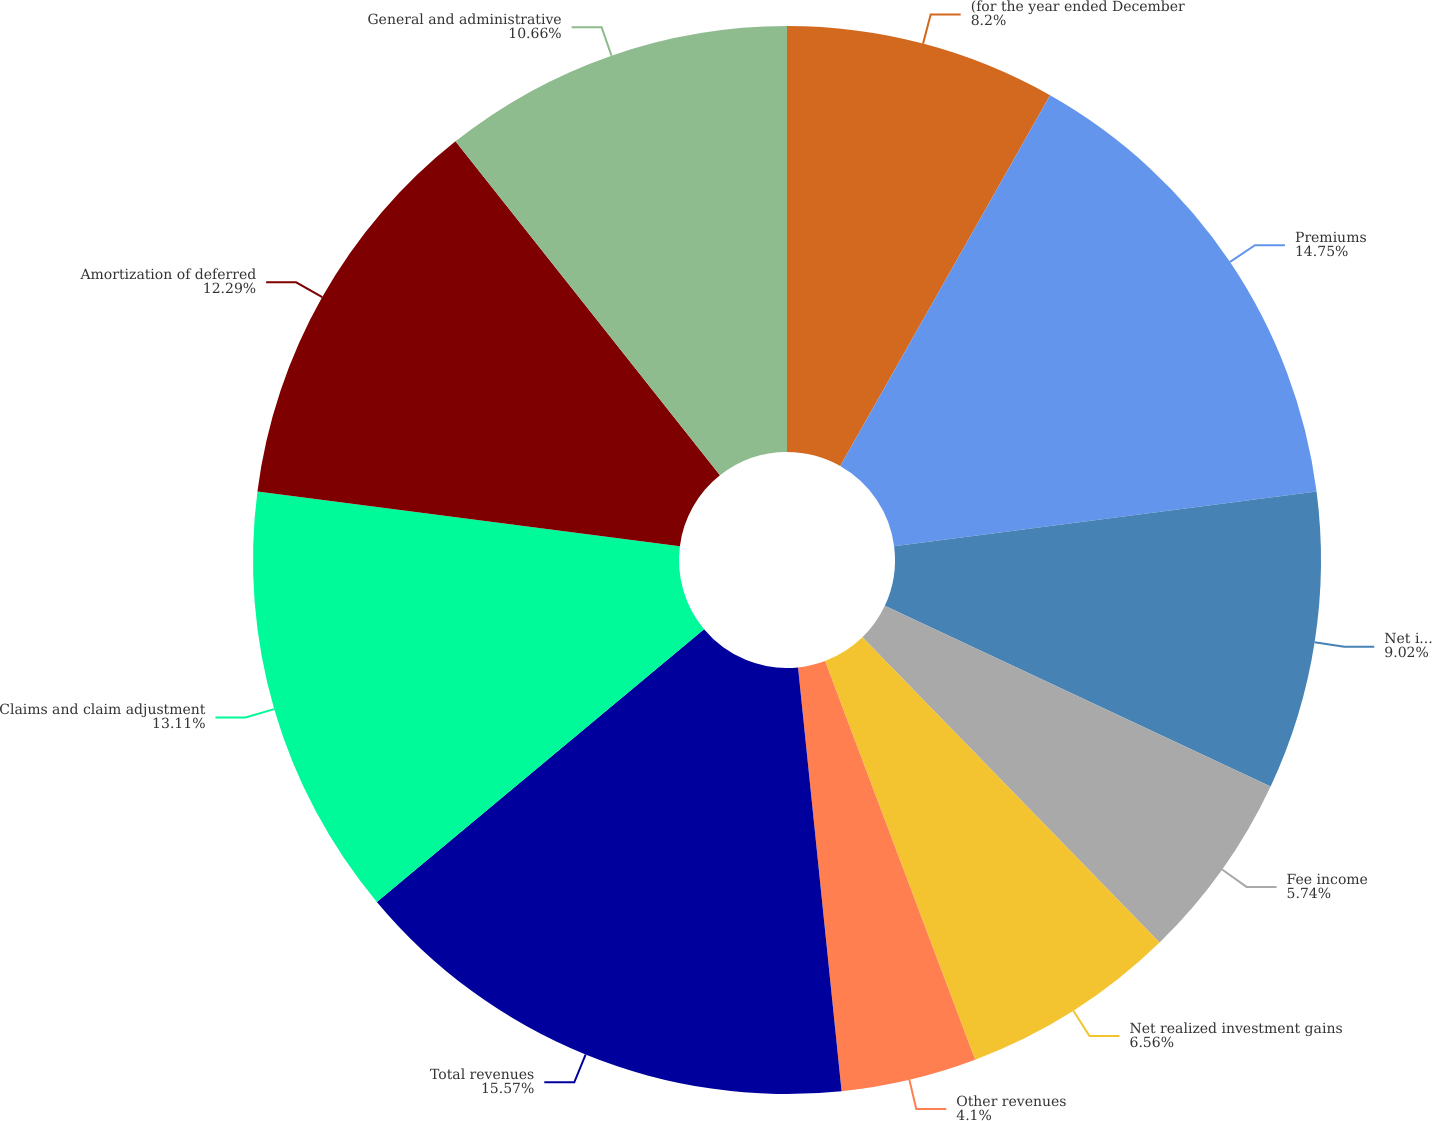Convert chart. <chart><loc_0><loc_0><loc_500><loc_500><pie_chart><fcel>(for the year ended December<fcel>Premiums<fcel>Net investment income<fcel>Fee income<fcel>Net realized investment gains<fcel>Other revenues<fcel>Total revenues<fcel>Claims and claim adjustment<fcel>Amortization of deferred<fcel>General and administrative<nl><fcel>8.2%<fcel>14.75%<fcel>9.02%<fcel>5.74%<fcel>6.56%<fcel>4.1%<fcel>15.57%<fcel>13.11%<fcel>12.29%<fcel>10.66%<nl></chart> 